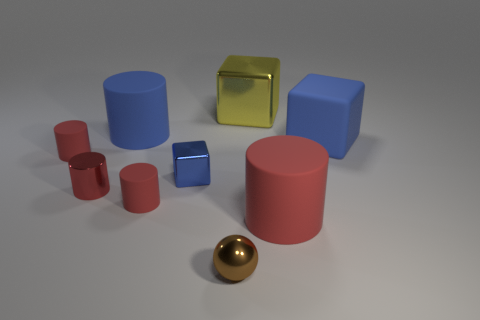Subtract all yellow balls. How many blue blocks are left? 2 Subtract all blue blocks. How many blocks are left? 1 Subtract all blue cylinders. How many cylinders are left? 4 Add 1 tiny blocks. How many objects exist? 10 Subtract all cyan cubes. Subtract all red cylinders. How many cubes are left? 3 Subtract 0 cyan blocks. How many objects are left? 9 Subtract all cubes. How many objects are left? 6 Subtract all small red matte cylinders. Subtract all large yellow shiny objects. How many objects are left? 6 Add 7 small red matte things. How many small red matte things are left? 9 Add 5 small brown shiny spheres. How many small brown shiny spheres exist? 6 